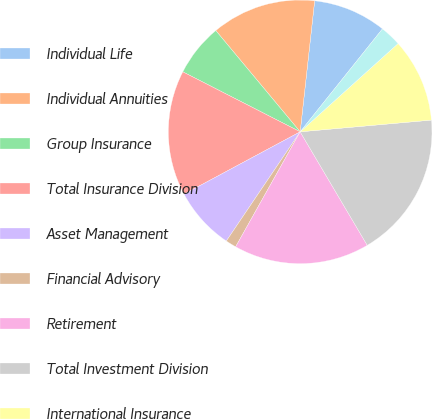<chart> <loc_0><loc_0><loc_500><loc_500><pie_chart><fcel>Individual Life<fcel>Individual Annuities<fcel>Group Insurance<fcel>Total Insurance Division<fcel>Asset Management<fcel>Financial Advisory<fcel>Retirement<fcel>Total Investment Division<fcel>International Insurance<fcel>International Investments<nl><fcel>8.98%<fcel>12.81%<fcel>6.42%<fcel>15.36%<fcel>7.7%<fcel>1.32%<fcel>16.64%<fcel>17.92%<fcel>10.26%<fcel>2.59%<nl></chart> 